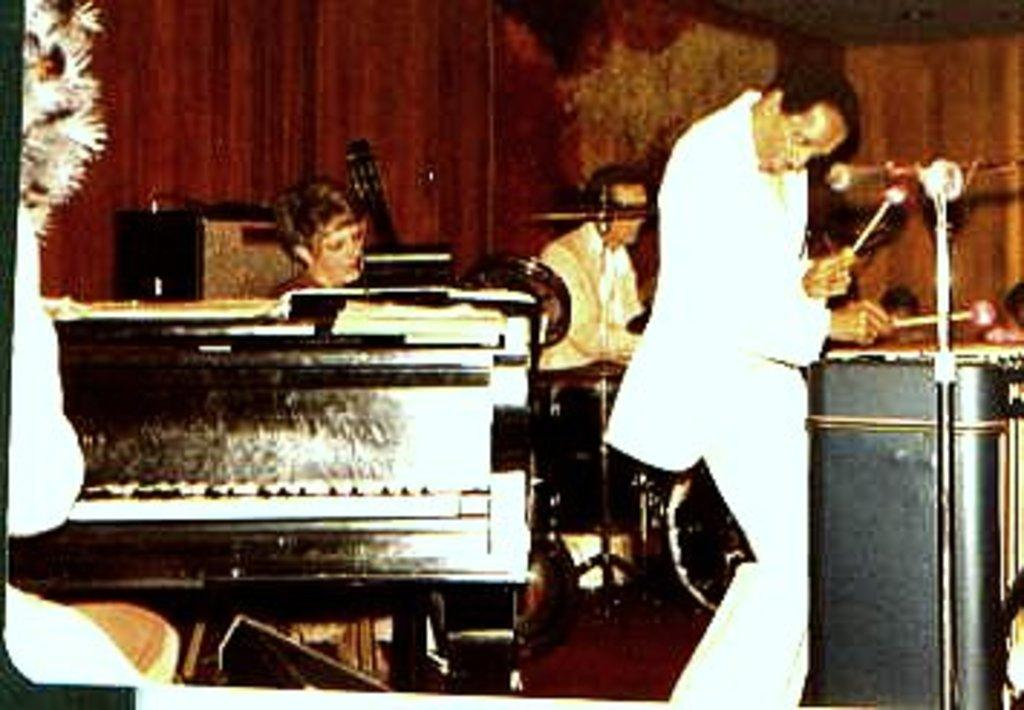What type of space is depicted in the image? There is a room in the image. What can be seen inside the room? There are multiple musical instruments in the room. What are the people in the room doing? There are people playing music in the room. How many horns are visible on the giants in the image? There are no giants or horns present in the image; it features a room with people playing musical instruments. 